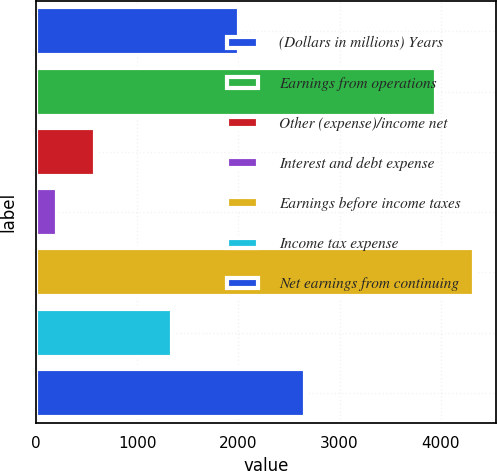<chart> <loc_0><loc_0><loc_500><loc_500><bar_chart><fcel>(Dollars in millions) Years<fcel>Earnings from operations<fcel>Other (expense)/income net<fcel>Interest and debt expense<fcel>Earnings before income taxes<fcel>Income tax expense<fcel>Net earnings from continuing<nl><fcel>2008<fcel>3950<fcel>581.3<fcel>202<fcel>4329.3<fcel>1341<fcel>2654<nl></chart> 